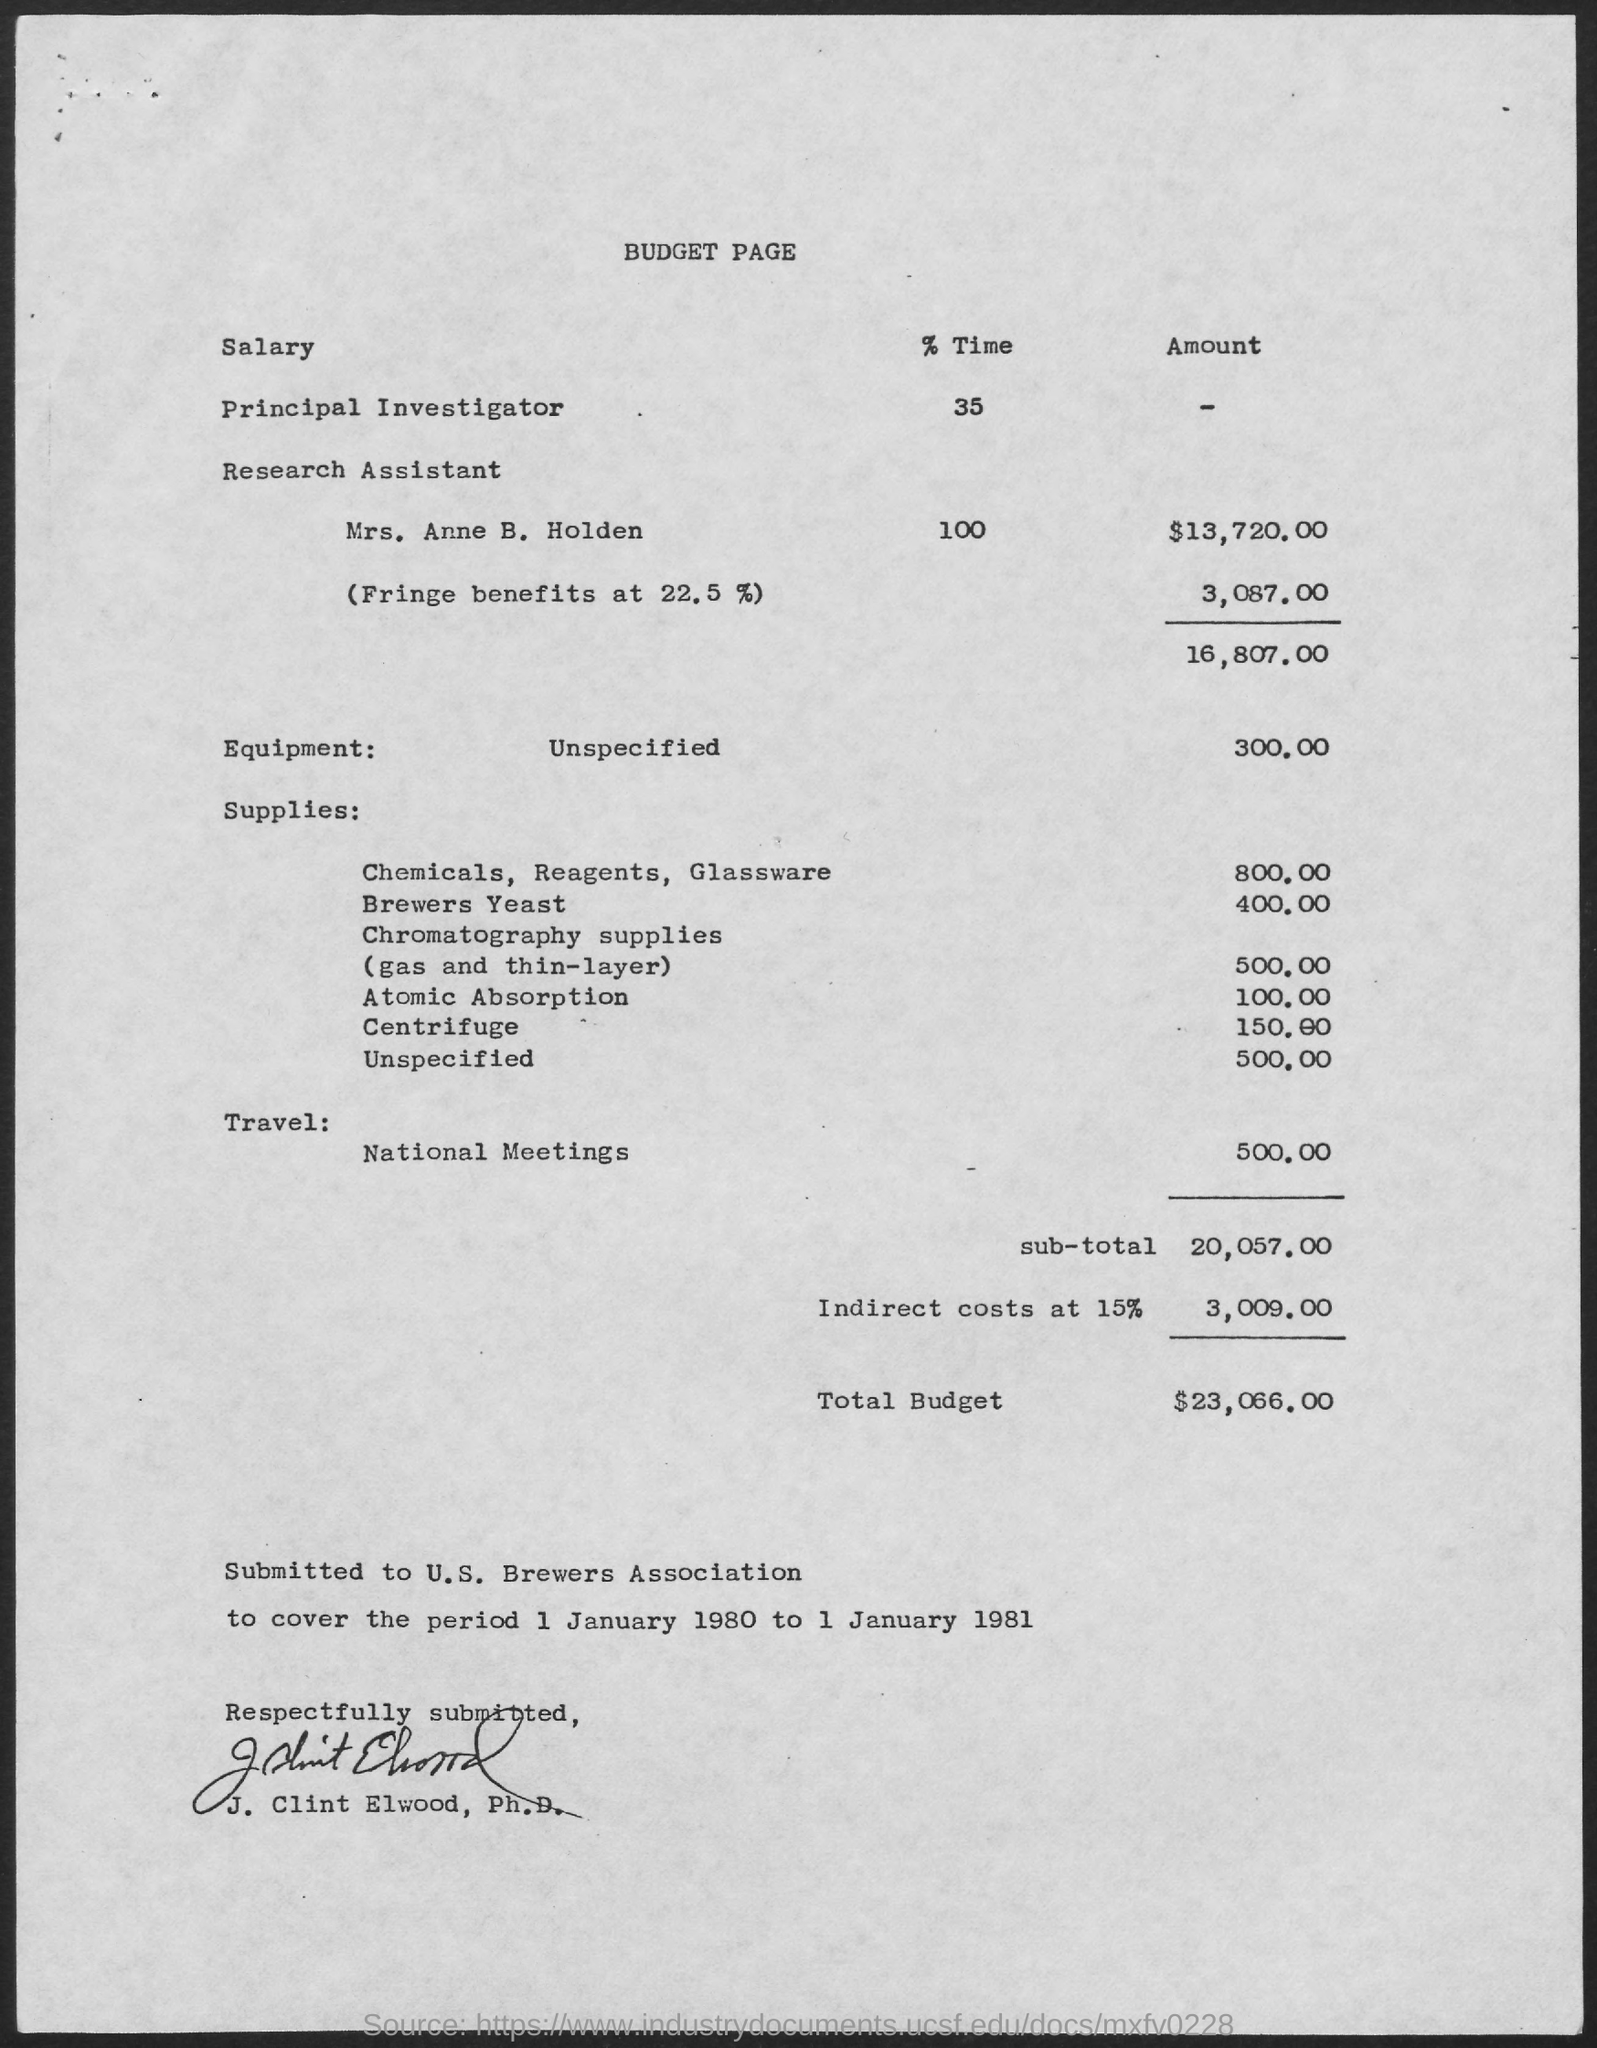What is the heading of the page?
Give a very brief answer. Budget page. What is the amount of total budget?
Offer a terse response. $23,066.00. What is the amount of sub-total ?
Offer a very short reply. 20,057.00. To whom is this bill submitted to?
Make the answer very short. U.S. Brewers Association. What is the period that has to be covered by u.s. brewers association?
Provide a short and direct response. 1 January 1980 to 1 January 1981. 